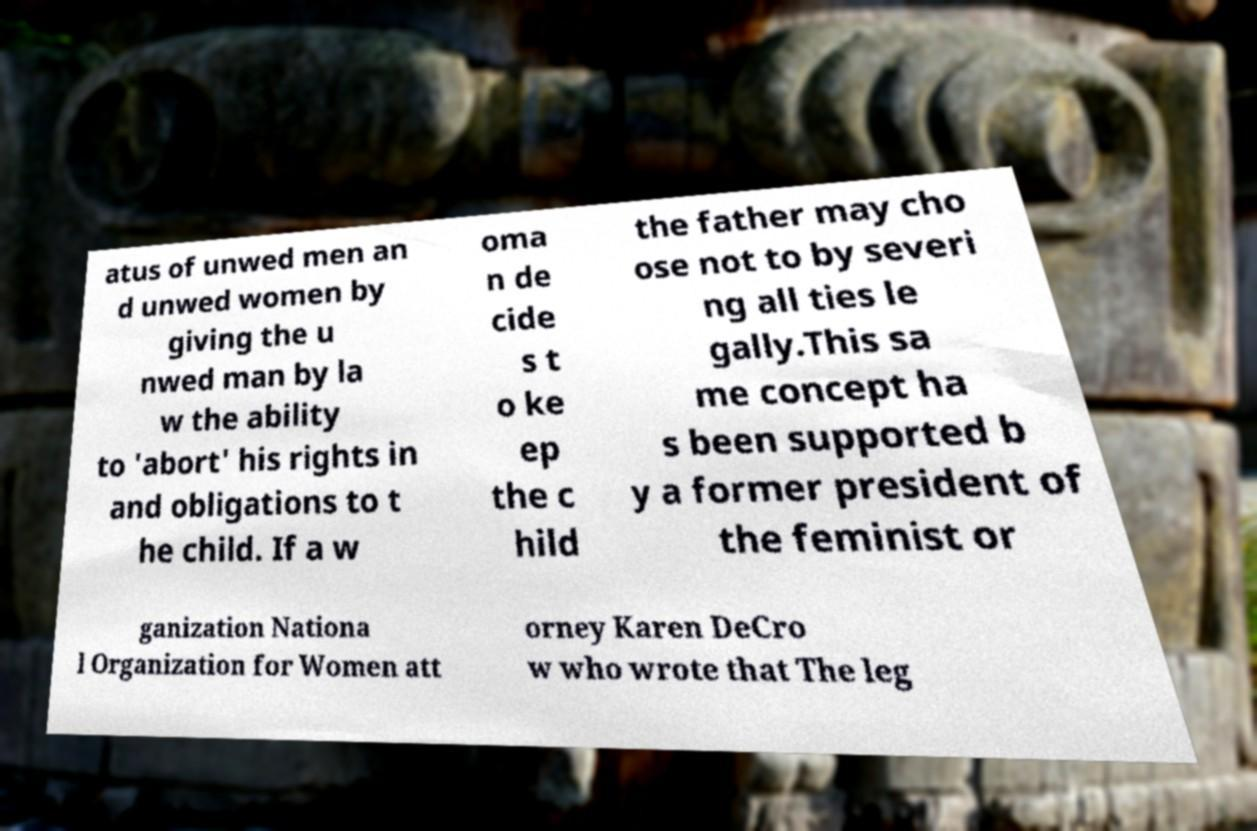Please read and relay the text visible in this image. What does it say? atus of unwed men an d unwed women by giving the u nwed man by la w the ability to 'abort' his rights in and obligations to t he child. If a w oma n de cide s t o ke ep the c hild the father may cho ose not to by severi ng all ties le gally.This sa me concept ha s been supported b y a former president of the feminist or ganization Nationa l Organization for Women att orney Karen DeCro w who wrote that The leg 